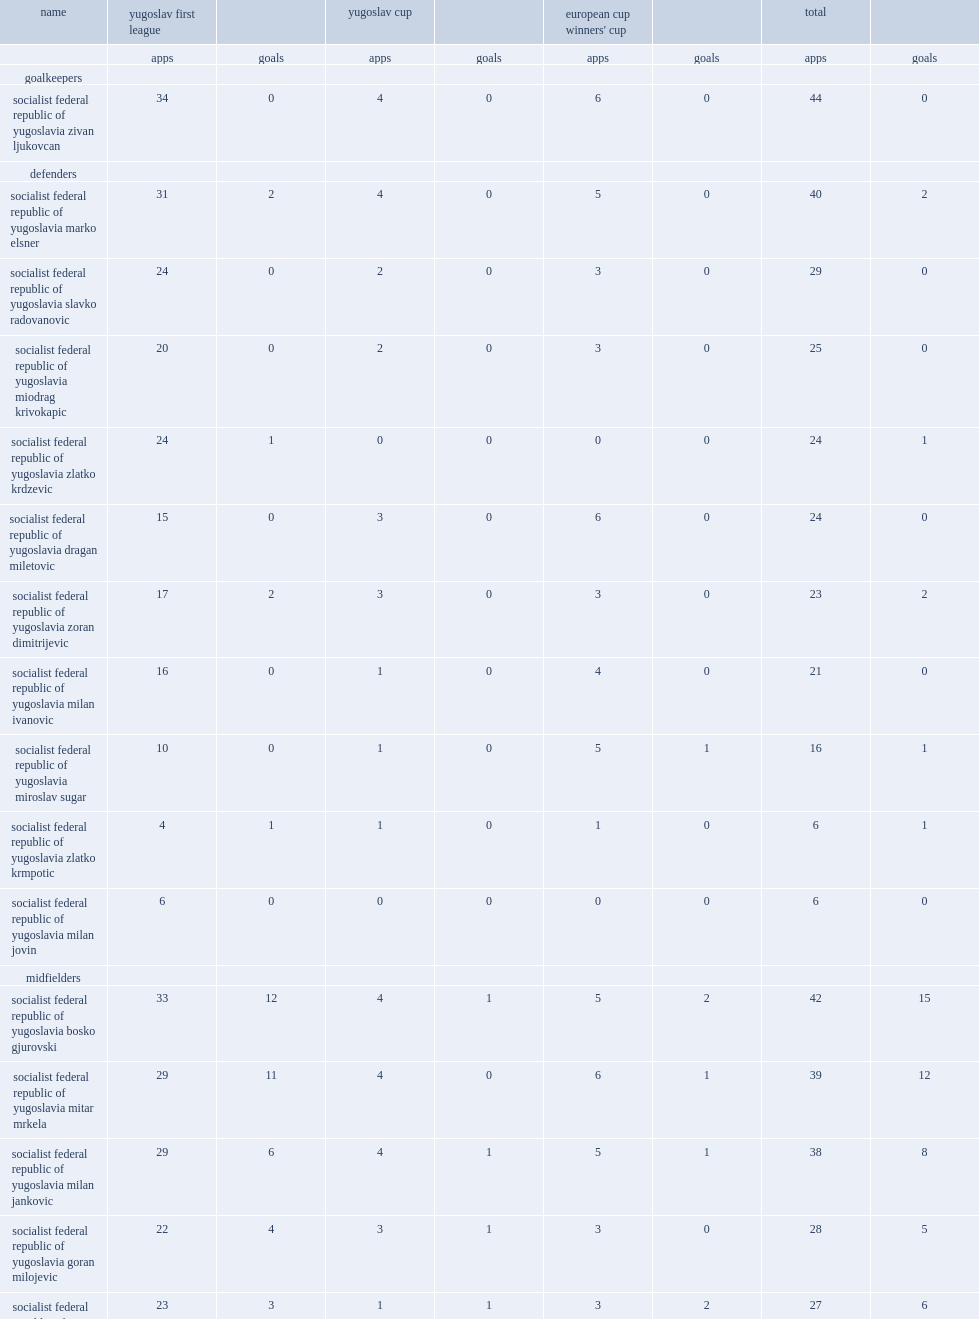During the 1985-86 season, what leagues and cups did red star belgrade participate in? Yugoslav first league yugoslav cup european cup winners' cup. 